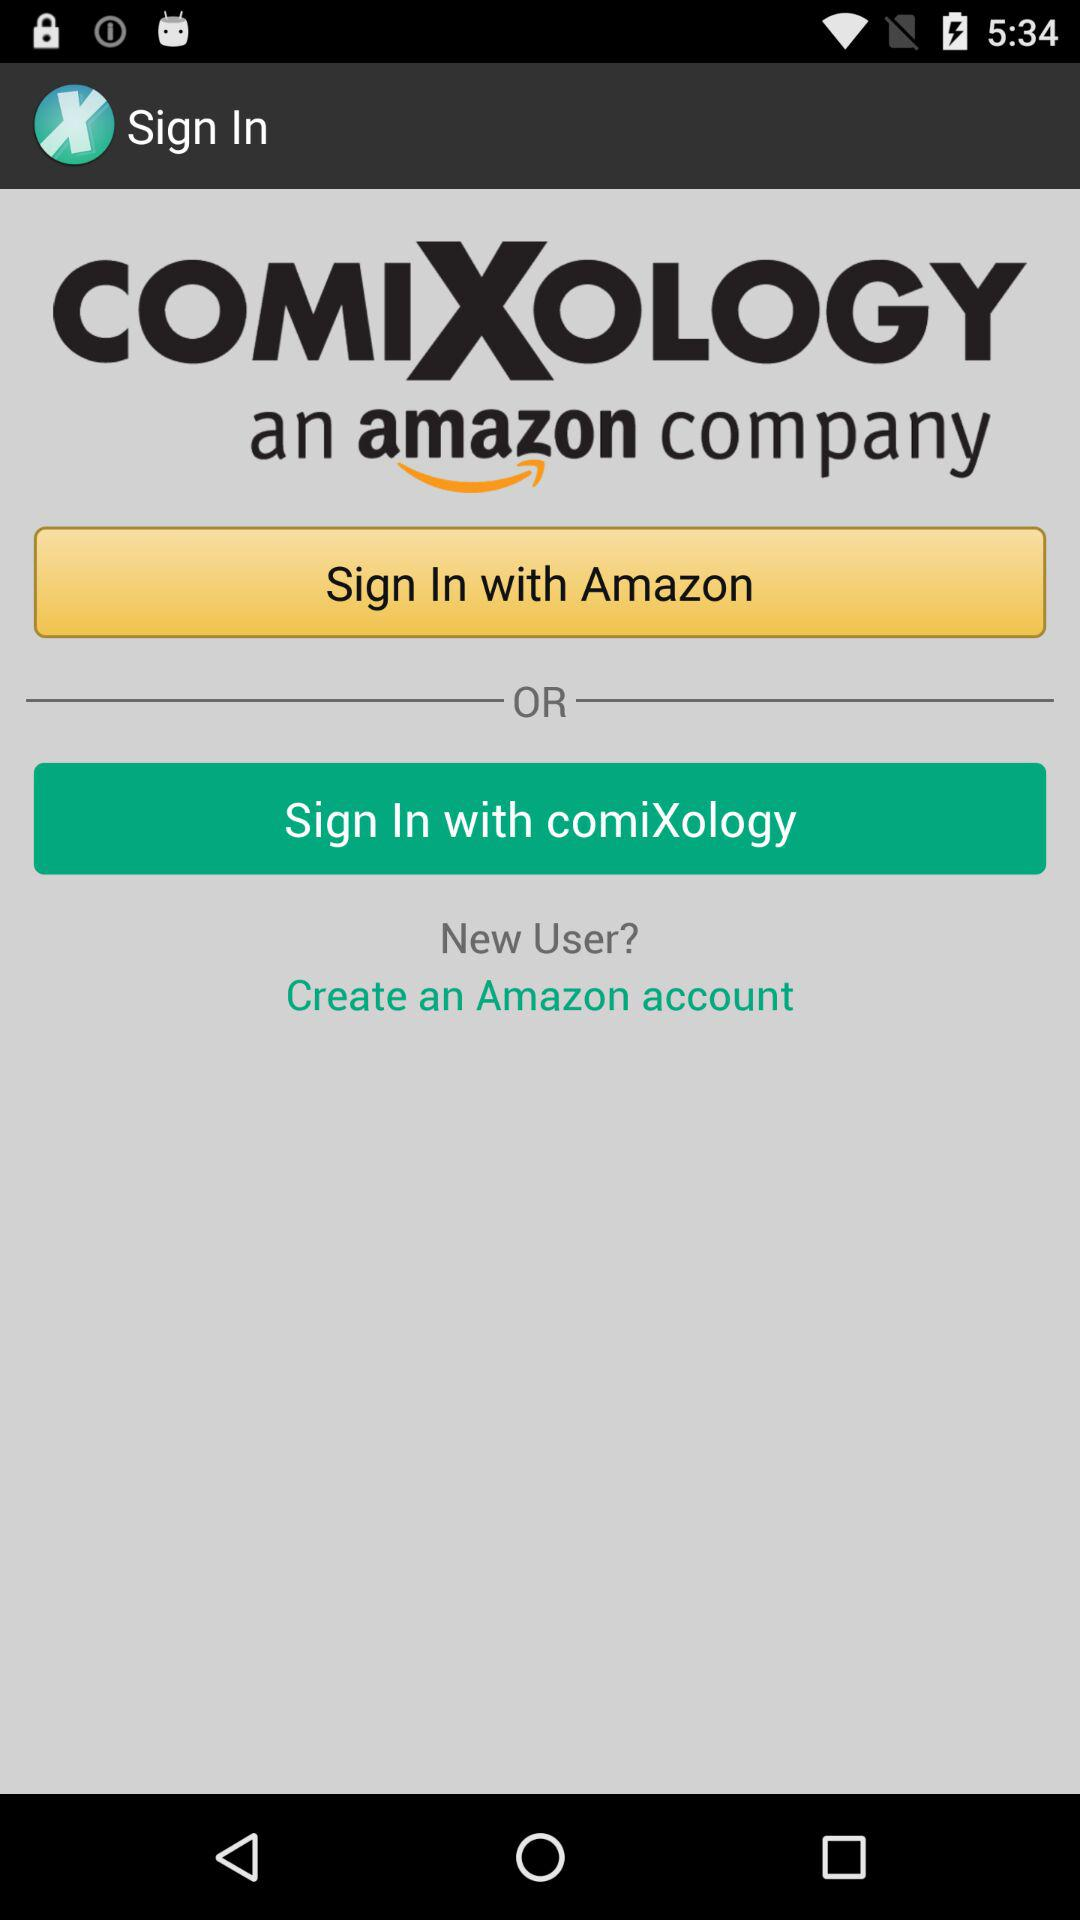With which app can we log in? You can log in with "Amazon" and "comiXology". 